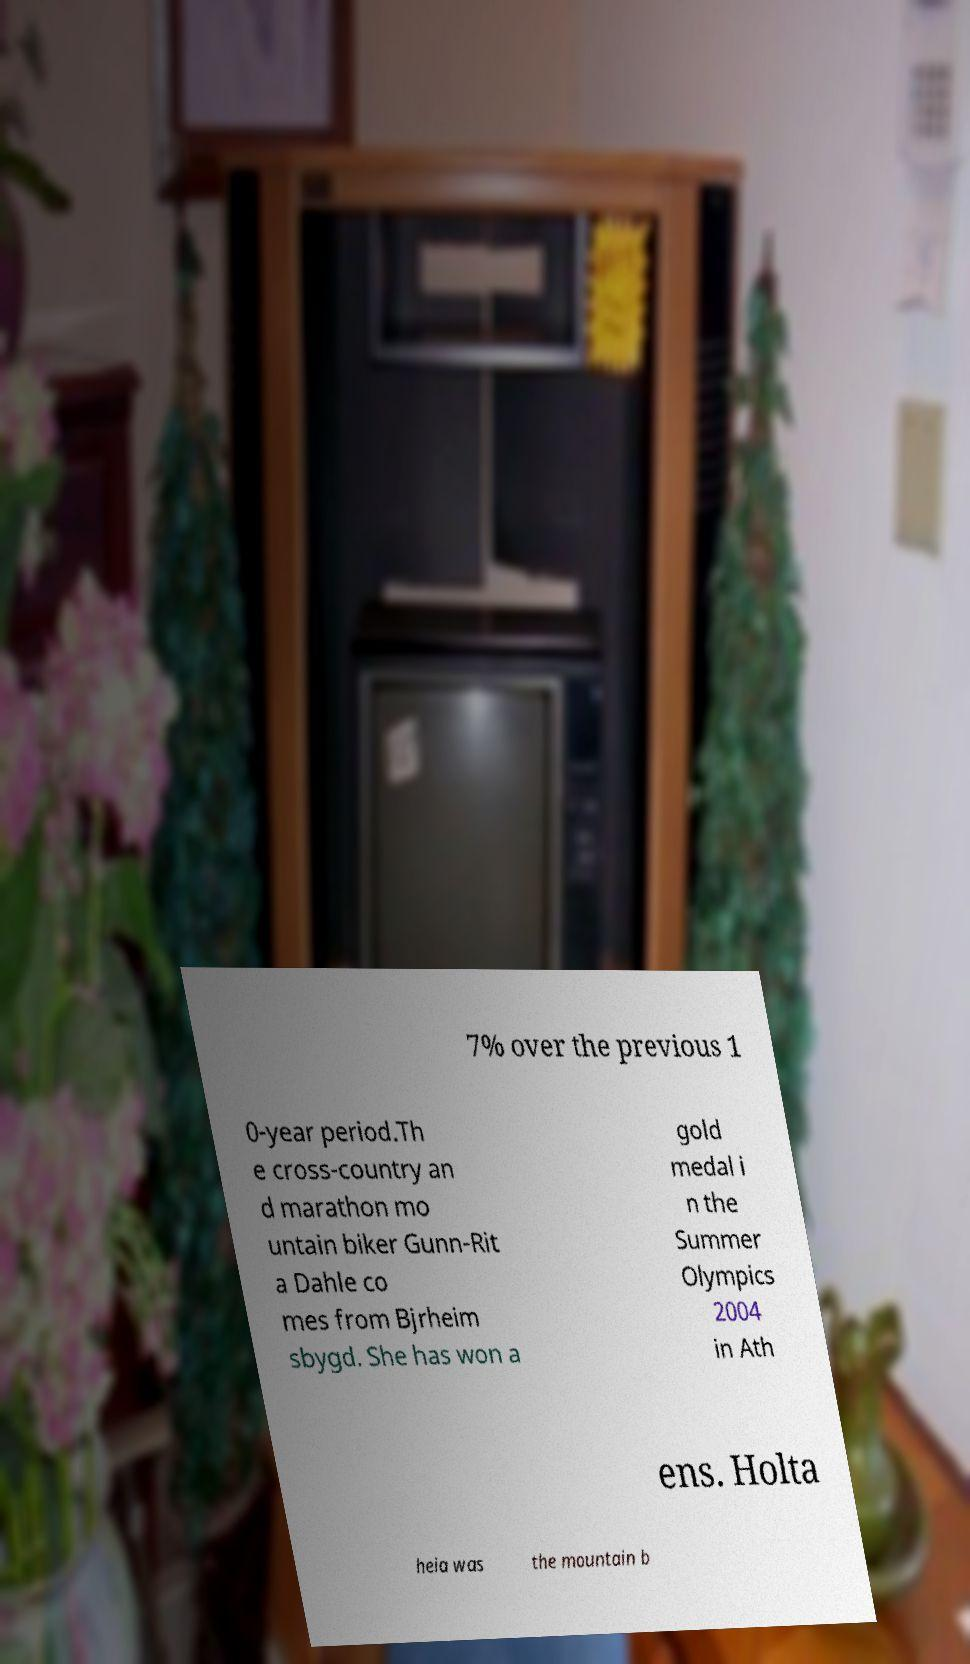Could you assist in decoding the text presented in this image and type it out clearly? 7% over the previous 1 0-year period.Th e cross-country an d marathon mo untain biker Gunn-Rit a Dahle co mes from Bjrheim sbygd. She has won a gold medal i n the Summer Olympics 2004 in Ath ens. Holta heia was the mountain b 